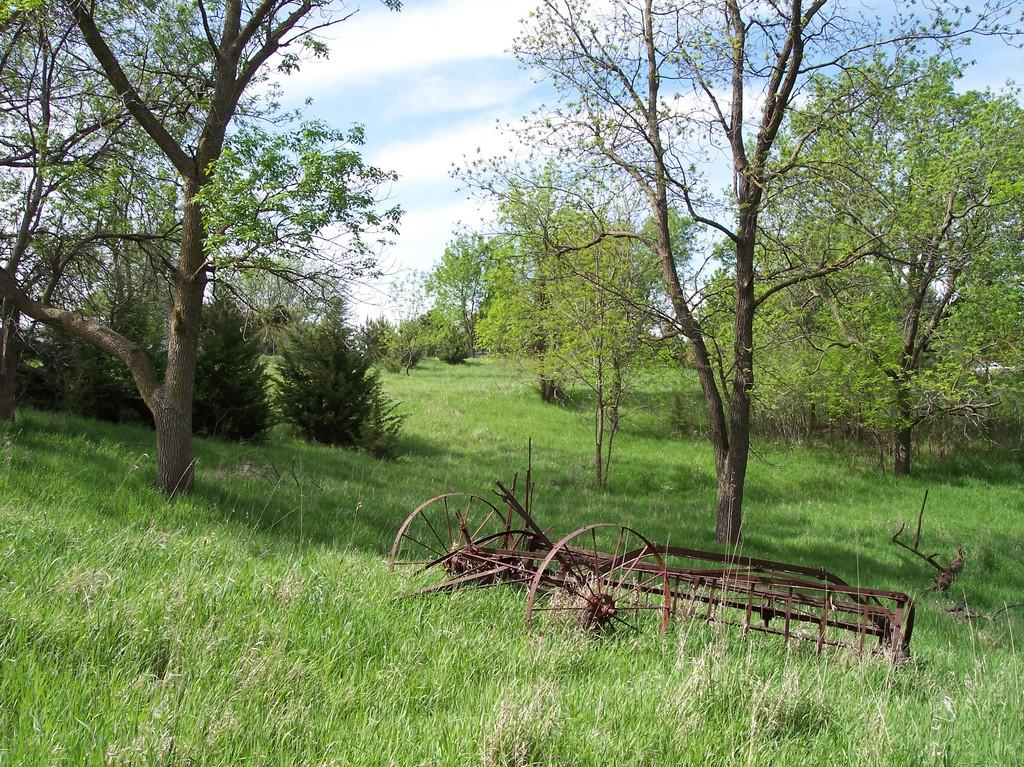What is the main subject of the image? The main subject of the image is a damaged wheel cart. Where is the wheel cart located? The wheel cart is on the grass. What can be seen in the background of the image? There are trees visible in the image. What is visible at the top of the image? The sky is visible at the top of the image. How many apples are hanging from the trees in the image? There are no apples visible in the image; only trees are present in the background. What type of cloth is draped over the damaged wheel cart? There is no cloth draped over the damaged wheel cart in the image. 